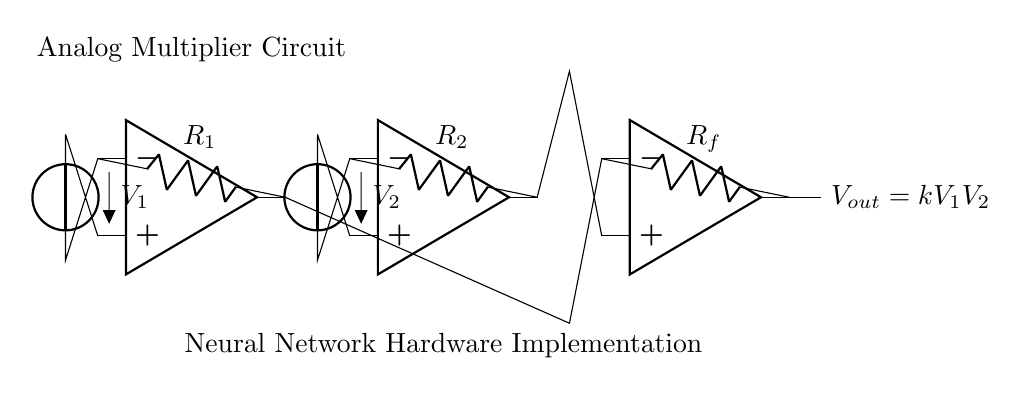What are the input voltages in the circuit? The circuit has two input voltage sources labeled V1 and V2. These are connected to the non-inverting inputs of the first two operational amplifiers.
Answer: V1, V2 What is the output voltage formula derived from this circuit? The output voltage is given by the equation Vout = k V1 V2, where k is a constant determined by the resistors in the circuit. This relationship comes from how the operational amplifiers and resistors interact.
Answer: Vout = k V1 V2 What type of circuit is this? This circuit is classified as an analog multiplier circuit, which is specifically designed to perform multiplication of the input voltages using analog components.
Answer: Analog multiplier How many operational amplifiers are used in this circuit? The circuit contains three operational amplifiers. Each performs specific functions to implement the multiplication of inputs and feedback.
Answer: Three What do the resistors do in this circuit? The resistors R1, R2, and Rf are used to set the gain and influence the output voltage level based on the characteristics of the operational amplifiers. Their values determine how V1 and V2 are combined.
Answer: Set gain What is the significance of the feedback resistor Rf? The feedback resistor Rf connects the output of the last operational amplifier to its inverting input and plays a crucial role in defining how the output voltage relates to the input voltages combined through the earlier amplifiers. This often stabilizes the circuit and sets the gain of the operation.
Answer: Stabilizes the circuit What type of application could this circuit be used for? This circuit can be used for hardware implementations of neural networks, as it can multiply input signals, which is a fundamental operation in many artificial neural network algorithms.
Answer: Neural networks 